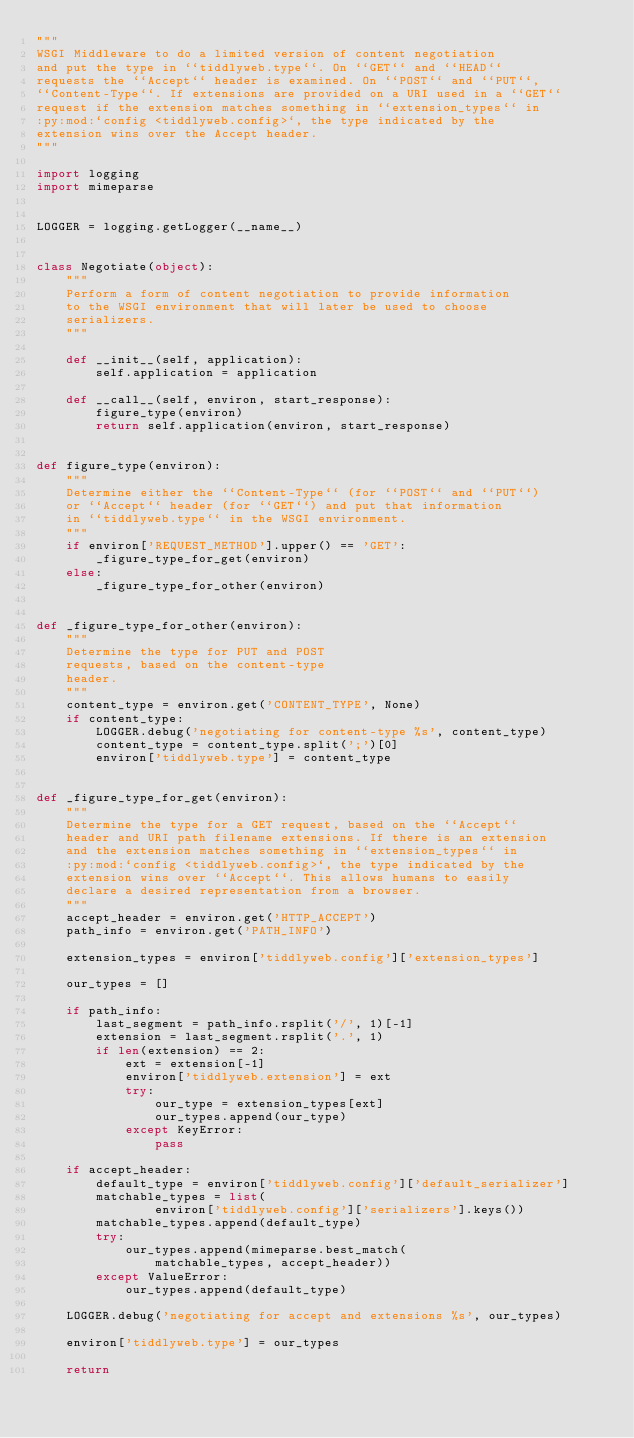<code> <loc_0><loc_0><loc_500><loc_500><_Python_>"""
WSGI Middleware to do a limited version of content negotiation
and put the type in ``tiddlyweb.type``. On ``GET`` and ``HEAD``
requests the ``Accept`` header is examined. On ``POST`` and ``PUT``,
``Content-Type``. If extensions are provided on a URI used in a ``GET``
request if the extension matches something in ``extension_types`` in
:py:mod:`config <tiddlyweb.config>`, the type indicated by the
extension wins over the Accept header.
"""

import logging
import mimeparse


LOGGER = logging.getLogger(__name__)


class Negotiate(object):
    """
    Perform a form of content negotiation to provide information
    to the WSGI environment that will later be used to choose
    serializers.
    """

    def __init__(self, application):
        self.application = application

    def __call__(self, environ, start_response):
        figure_type(environ)
        return self.application(environ, start_response)


def figure_type(environ):
    """
    Determine either the ``Content-Type`` (for ``POST`` and ``PUT``)
    or ``Accept`` header (for ``GET``) and put that information
    in ``tiddlyweb.type`` in the WSGI environment.
    """
    if environ['REQUEST_METHOD'].upper() == 'GET':
        _figure_type_for_get(environ)
    else:
        _figure_type_for_other(environ)


def _figure_type_for_other(environ):
    """
    Determine the type for PUT and POST
    requests, based on the content-type
    header.
    """
    content_type = environ.get('CONTENT_TYPE', None)
    if content_type:
        LOGGER.debug('negotiating for content-type %s', content_type)
        content_type = content_type.split(';')[0]
        environ['tiddlyweb.type'] = content_type


def _figure_type_for_get(environ):
    """
    Determine the type for a GET request, based on the ``Accept``
    header and URI path filename extensions. If there is an extension
    and the extension matches something in ``extension_types`` in
    :py:mod:`config <tiddlyweb.config>`, the type indicated by the
    extension wins over ``Accept``. This allows humans to easily
    declare a desired representation from a browser.
    """
    accept_header = environ.get('HTTP_ACCEPT')
    path_info = environ.get('PATH_INFO')

    extension_types = environ['tiddlyweb.config']['extension_types']

    our_types = []

    if path_info:
        last_segment = path_info.rsplit('/', 1)[-1]
        extension = last_segment.rsplit('.', 1)
        if len(extension) == 2:
            ext = extension[-1]
            environ['tiddlyweb.extension'] = ext
            try:
                our_type = extension_types[ext]
                our_types.append(our_type)
            except KeyError:
                pass

    if accept_header:
        default_type = environ['tiddlyweb.config']['default_serializer']
        matchable_types = list(
                environ['tiddlyweb.config']['serializers'].keys())
        matchable_types.append(default_type)
        try:
            our_types.append(mimeparse.best_match(
                matchable_types, accept_header))
        except ValueError:
            our_types.append(default_type)

    LOGGER.debug('negotiating for accept and extensions %s', our_types)

    environ['tiddlyweb.type'] = our_types

    return
</code> 